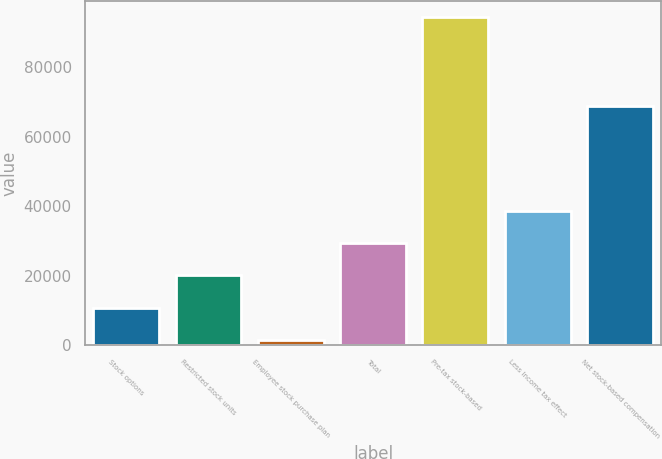Convert chart to OTSL. <chart><loc_0><loc_0><loc_500><loc_500><bar_chart><fcel>Stock options<fcel>Restricted stock units<fcel>Employee stock purchase plan<fcel>Total<fcel>Pre-tax stock-based<fcel>Less Income tax effect<fcel>Net stock-based compensation<nl><fcel>10830.1<fcel>20104.2<fcel>1556<fcel>29378.3<fcel>94297<fcel>38652.4<fcel>68840<nl></chart> 